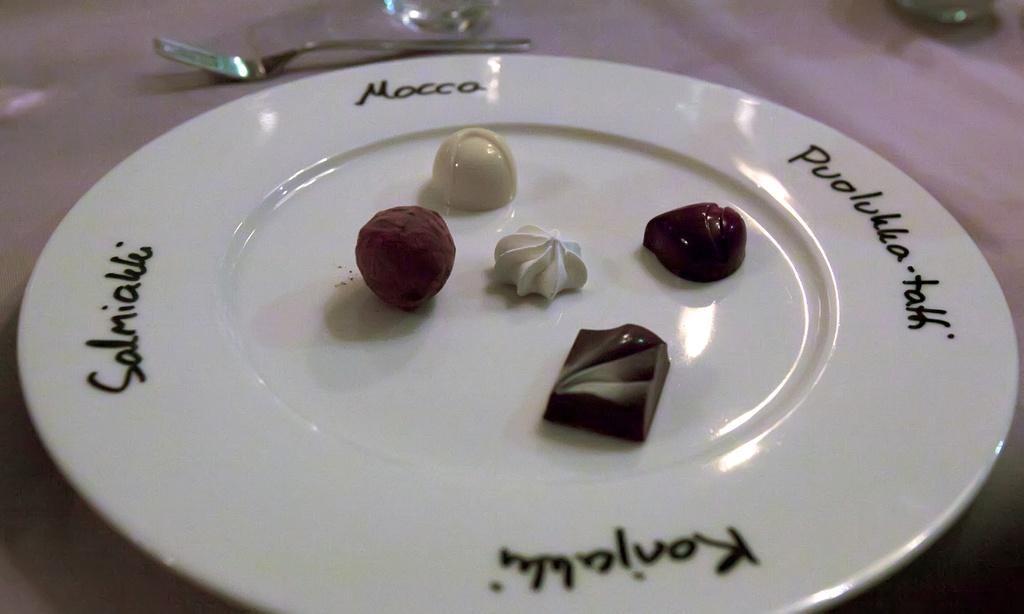Can you describe this image briefly? In this image we can see a plate on a surface. On the plate we can see food item and text. At the top we can see a fork and an object. 